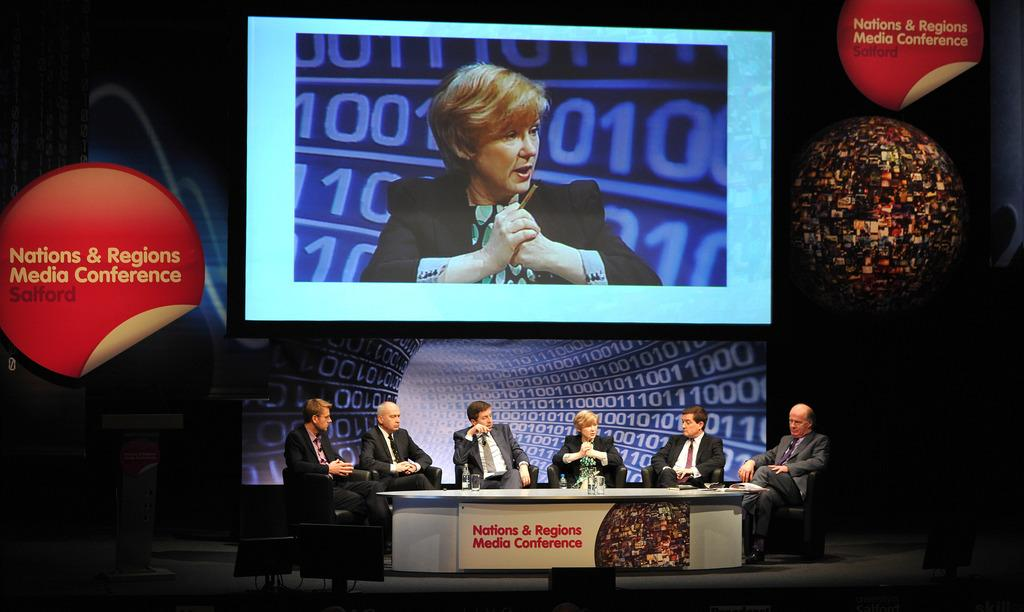Provide a one-sentence caption for the provided image. Six professionals take part in a media conference that's underway in Salford. 